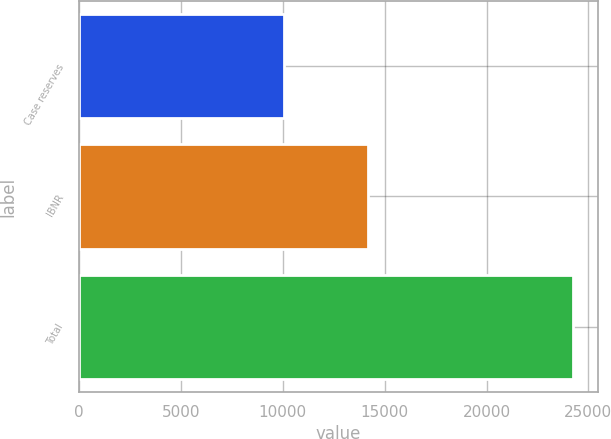Convert chart. <chart><loc_0><loc_0><loc_500><loc_500><bar_chart><fcel>Case reserves<fcel>IBNR<fcel>Total<nl><fcel>10044<fcel>14197<fcel>24241<nl></chart> 